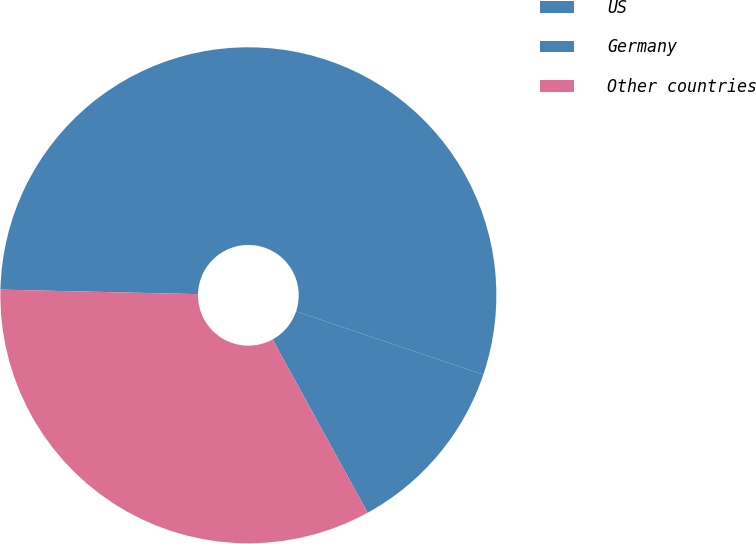<chart> <loc_0><loc_0><loc_500><loc_500><pie_chart><fcel>US<fcel>Germany<fcel>Other countries<nl><fcel>54.82%<fcel>11.83%<fcel>33.35%<nl></chart> 